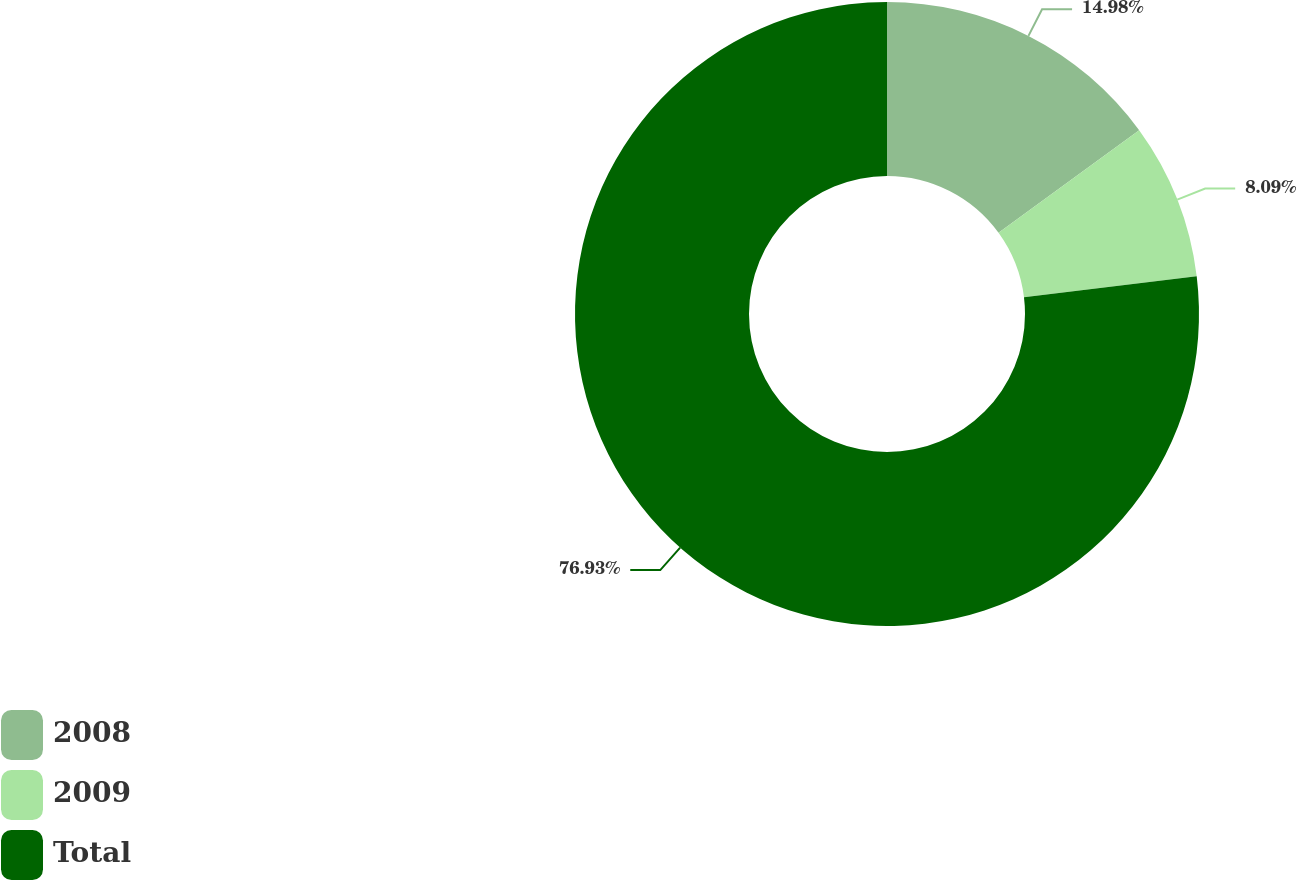Convert chart to OTSL. <chart><loc_0><loc_0><loc_500><loc_500><pie_chart><fcel>2008<fcel>2009<fcel>Total<nl><fcel>14.98%<fcel>8.09%<fcel>76.93%<nl></chart> 